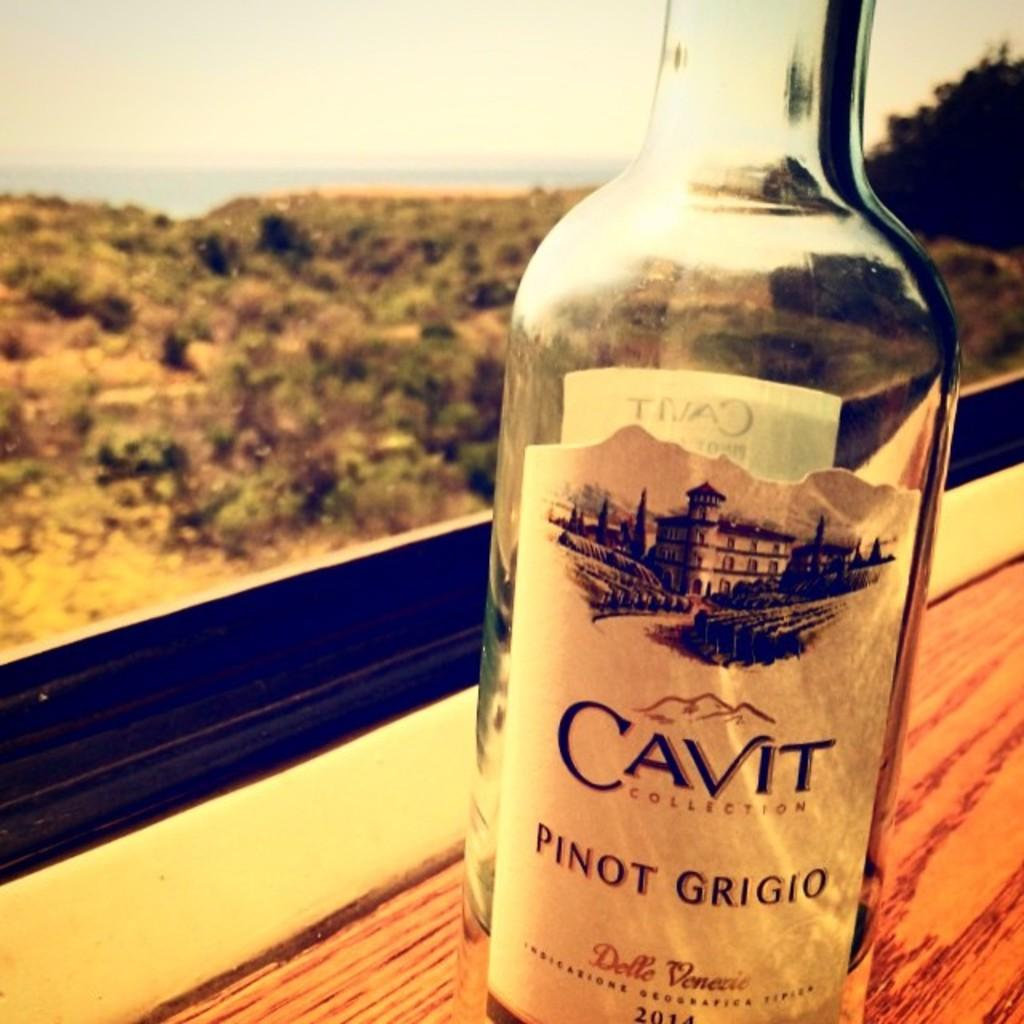<image>
Share a concise interpretation of the image provided. a cavit bottle that is on a brown table 